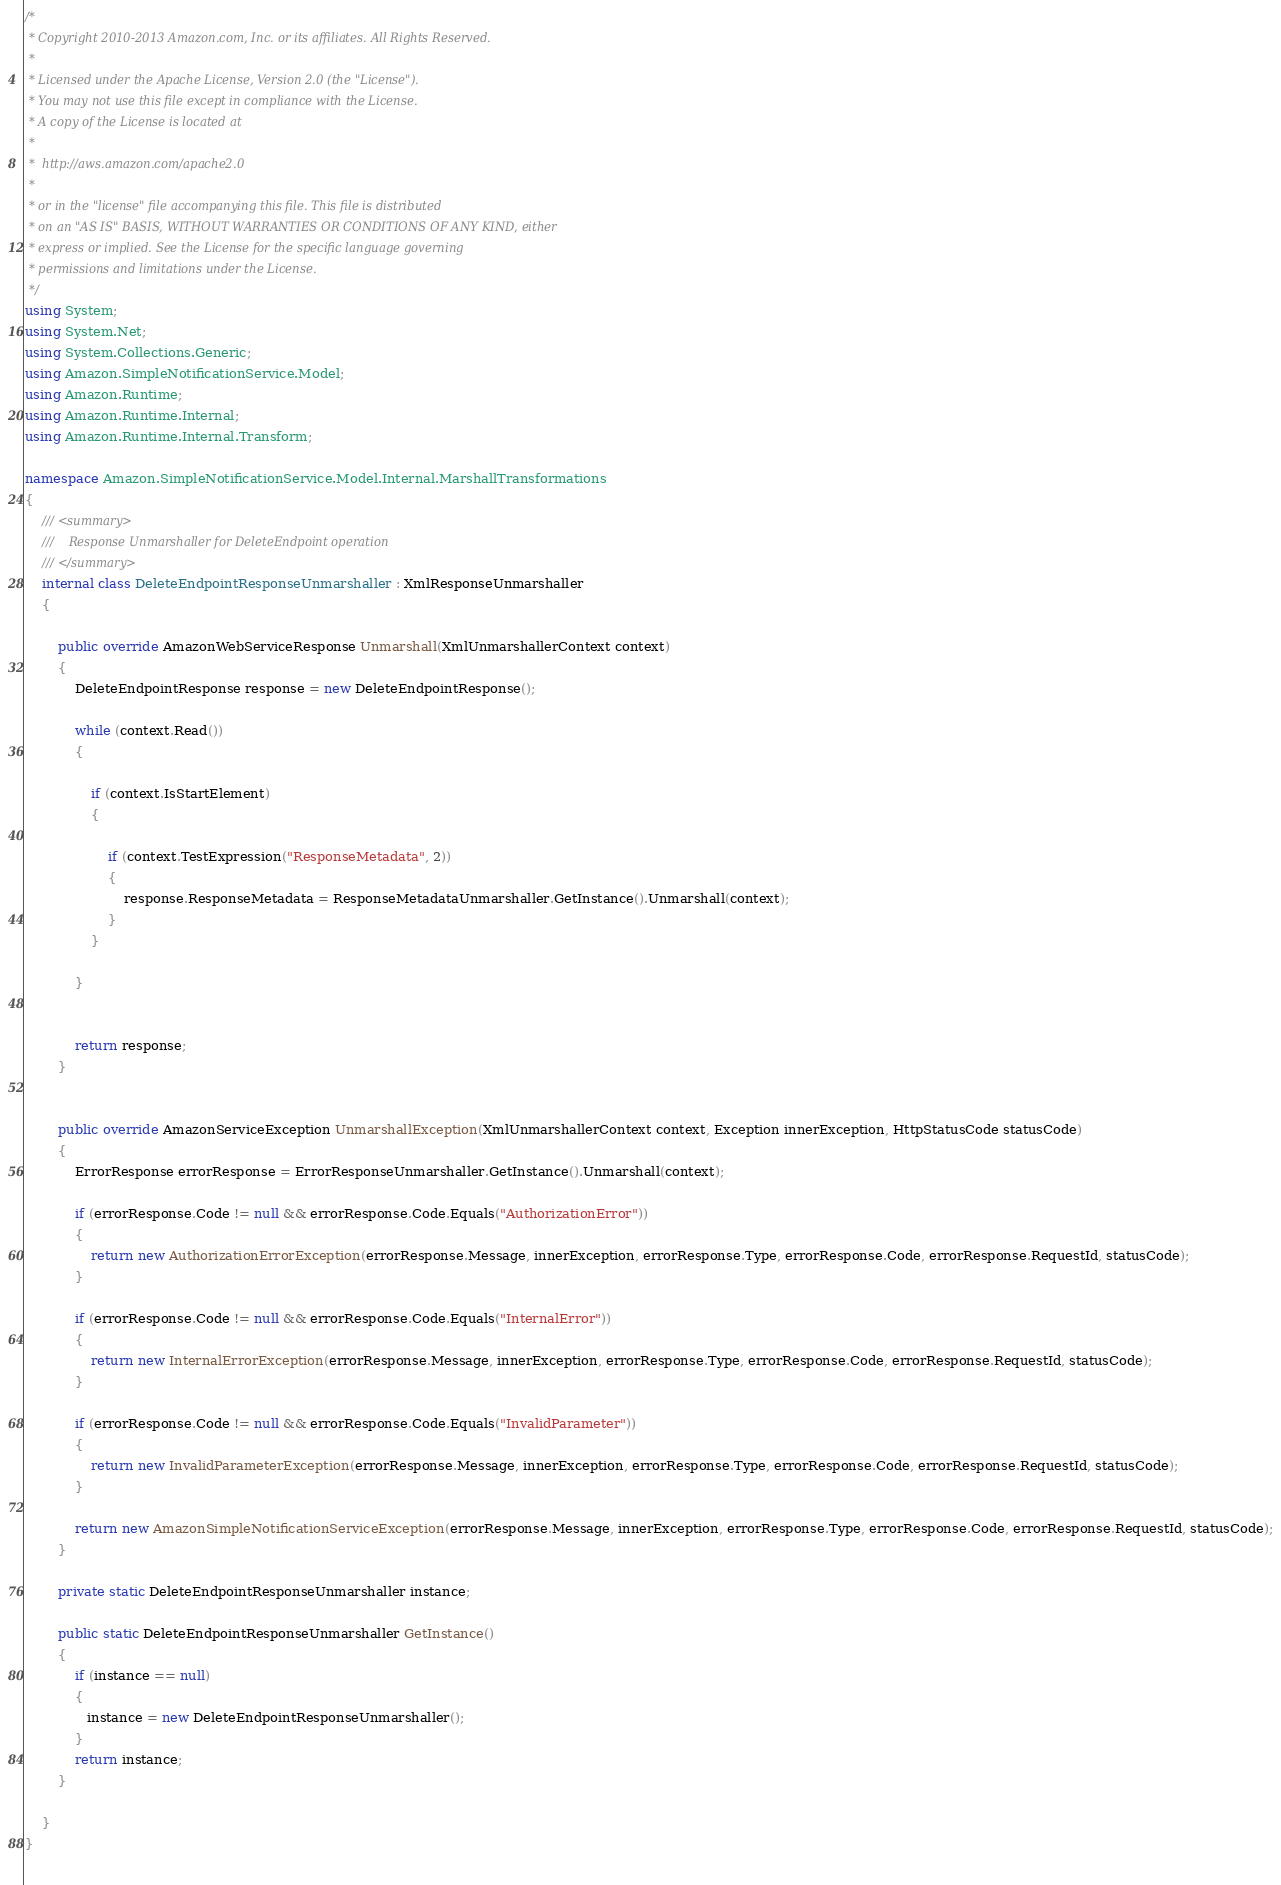<code> <loc_0><loc_0><loc_500><loc_500><_C#_>/*
 * Copyright 2010-2013 Amazon.com, Inc. or its affiliates. All Rights Reserved.
 * 
 * Licensed under the Apache License, Version 2.0 (the "License").
 * You may not use this file except in compliance with the License.
 * A copy of the License is located at
 * 
 *  http://aws.amazon.com/apache2.0
 * 
 * or in the "license" file accompanying this file. This file is distributed
 * on an "AS IS" BASIS, WITHOUT WARRANTIES OR CONDITIONS OF ANY KIND, either
 * express or implied. See the License for the specific language governing
 * permissions and limitations under the License.
 */
using System;
using System.Net;
using System.Collections.Generic;
using Amazon.SimpleNotificationService.Model;
using Amazon.Runtime;
using Amazon.Runtime.Internal;
using Amazon.Runtime.Internal.Transform;

namespace Amazon.SimpleNotificationService.Model.Internal.MarshallTransformations
{
    /// <summary>
    ///    Response Unmarshaller for DeleteEndpoint operation
    /// </summary>
    internal class DeleteEndpointResponseUnmarshaller : XmlResponseUnmarshaller
    {

        public override AmazonWebServiceResponse Unmarshall(XmlUnmarshallerContext context) 
        {
            DeleteEndpointResponse response = new DeleteEndpointResponse();
            
            while (context.Read())
            {
                
                if (context.IsStartElement)
                {
                    
                    if (context.TestExpression("ResponseMetadata", 2))
                    {
                        response.ResponseMetadata = ResponseMetadataUnmarshaller.GetInstance().Unmarshall(context);
                    }
                }
                
            }
                

            return response;
        }
        
        
        public override AmazonServiceException UnmarshallException(XmlUnmarshallerContext context, Exception innerException, HttpStatusCode statusCode)
        {
            ErrorResponse errorResponse = ErrorResponseUnmarshaller.GetInstance().Unmarshall(context);
            
            if (errorResponse.Code != null && errorResponse.Code.Equals("AuthorizationError"))
            {
                return new AuthorizationErrorException(errorResponse.Message, innerException, errorResponse.Type, errorResponse.Code, errorResponse.RequestId, statusCode);
            }
    
            if (errorResponse.Code != null && errorResponse.Code.Equals("InternalError"))
            {
                return new InternalErrorException(errorResponse.Message, innerException, errorResponse.Type, errorResponse.Code, errorResponse.RequestId, statusCode);
            }
    
            if (errorResponse.Code != null && errorResponse.Code.Equals("InvalidParameter"))
            {
                return new InvalidParameterException(errorResponse.Message, innerException, errorResponse.Type, errorResponse.Code, errorResponse.RequestId, statusCode);
            }
    
            return new AmazonSimpleNotificationServiceException(errorResponse.Message, innerException, errorResponse.Type, errorResponse.Code, errorResponse.RequestId, statusCode);
        }
        
        private static DeleteEndpointResponseUnmarshaller instance;

        public static DeleteEndpointResponseUnmarshaller GetInstance()
        {
            if (instance == null) 
            {
               instance = new DeleteEndpointResponseUnmarshaller();
            }
            return instance;
        }
    
    }
}
    
</code> 